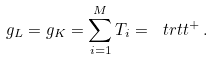<formula> <loc_0><loc_0><loc_500><loc_500>g _ { L } = g _ { K } = \sum _ { i = 1 } ^ { M } T _ { i } = \ t r t t ^ { + } \, .</formula> 